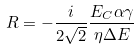Convert formula to latex. <formula><loc_0><loc_0><loc_500><loc_500>R = - \frac { i } { 2 \sqrt { 2 } } \frac { E _ { C } \alpha \gamma } { \eta \Delta E }</formula> 